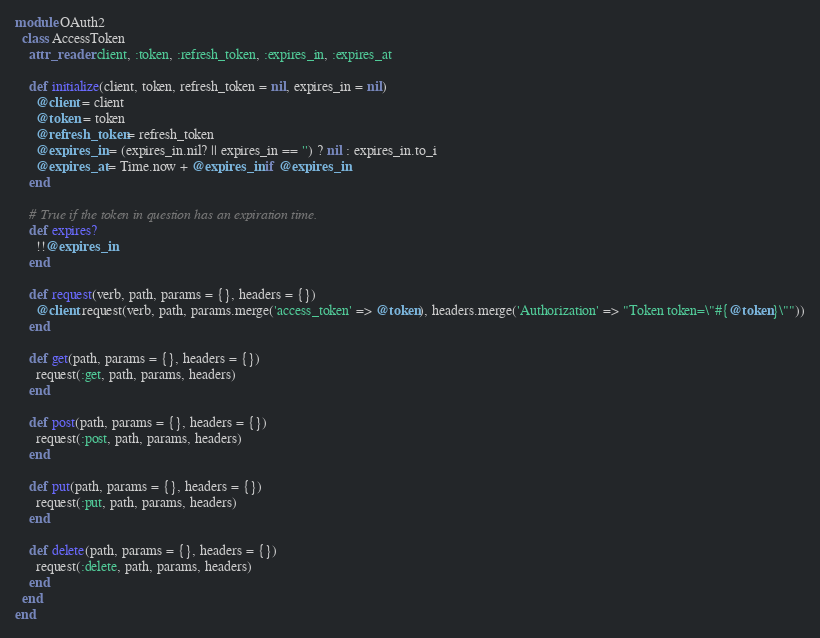<code> <loc_0><loc_0><loc_500><loc_500><_Ruby_>module OAuth2
  class AccessToken
    attr_reader :client, :token, :refresh_token, :expires_in, :expires_at

    def initialize(client, token, refresh_token = nil, expires_in = nil)
      @client = client
      @token = token
      @refresh_token = refresh_token
      @expires_in = (expires_in.nil? || expires_in == '') ? nil : expires_in.to_i
      @expires_at = Time.now + @expires_in if @expires_in
    end

    # True if the token in question has an expiration time.
    def expires?
      !!@expires_in
    end

    def request(verb, path, params = {}, headers = {})
      @client.request(verb, path, params.merge('access_token' => @token), headers.merge('Authorization' => "Token token=\"#{@token}\""))
    end

    def get(path, params = {}, headers = {})
      request(:get, path, params, headers)
    end

    def post(path, params = {}, headers = {})
      request(:post, path, params, headers)
    end

    def put(path, params = {}, headers = {})
      request(:put, path, params, headers)
    end

    def delete(path, params = {}, headers = {})
      request(:delete, path, params, headers)
    end
  end
end
</code> 